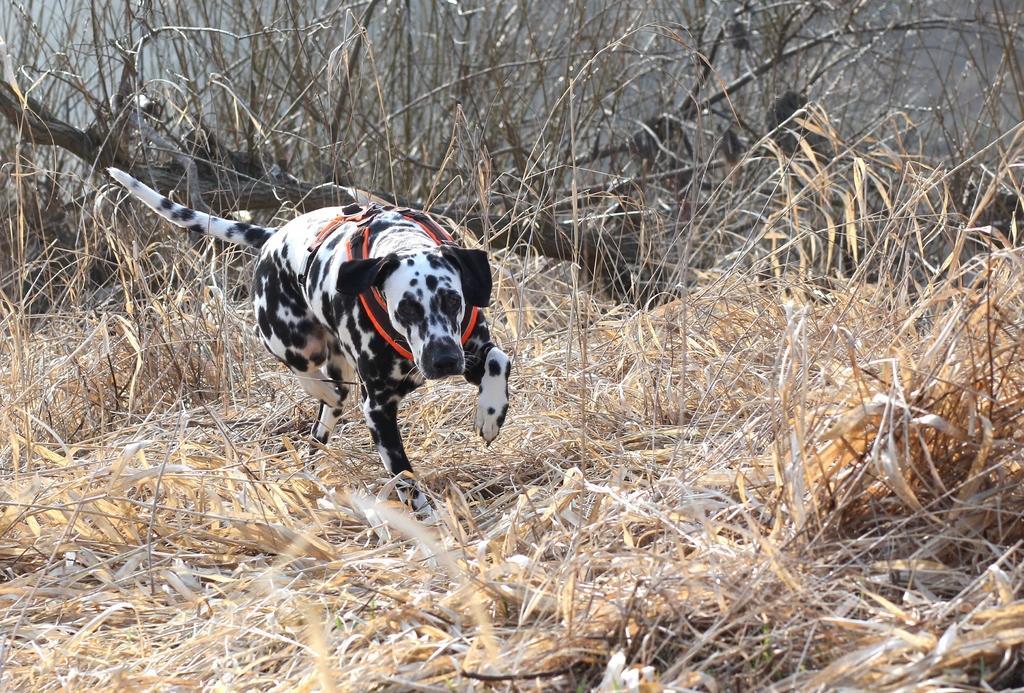Please provide a concise description of this image. In the image there is a dalmatian dog walking on the dry grassland. 